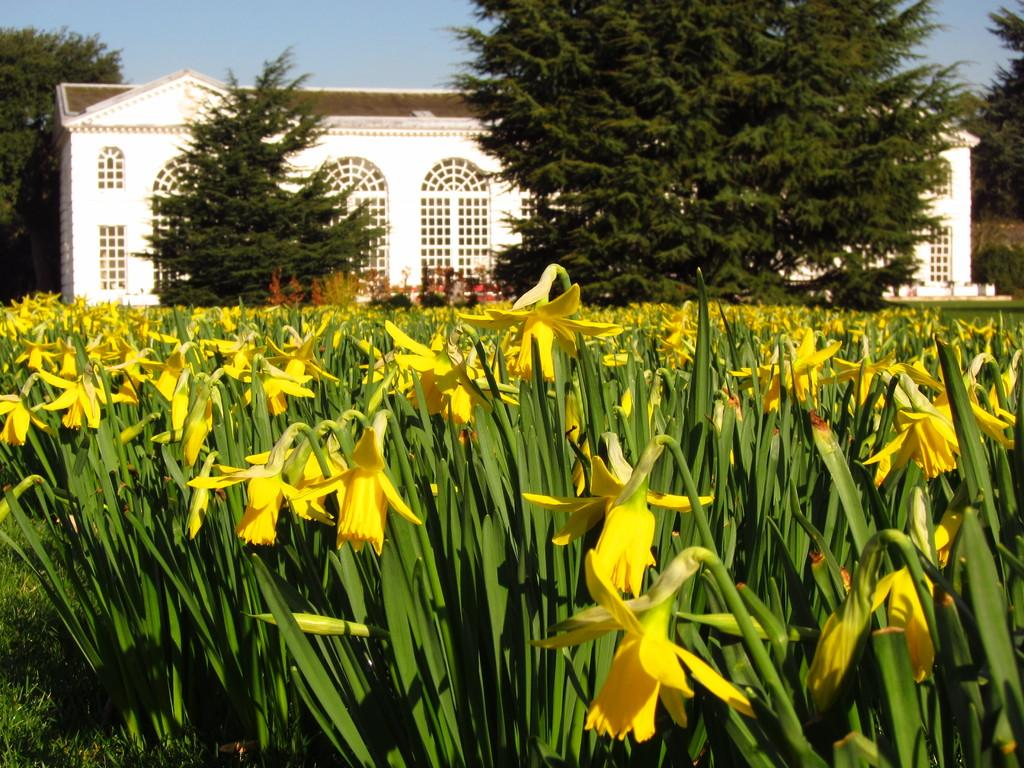What type of structure is visible in the image? There is a building in the image. What natural elements can be seen in the image? There are trees, plants, and flowers in the image. What is the color of the sky in the image? The sky is blue in the image. What type of advice can be seen written on the sponge in the image? There is no sponge present in the image, and therefore no advice can be seen written on it. 